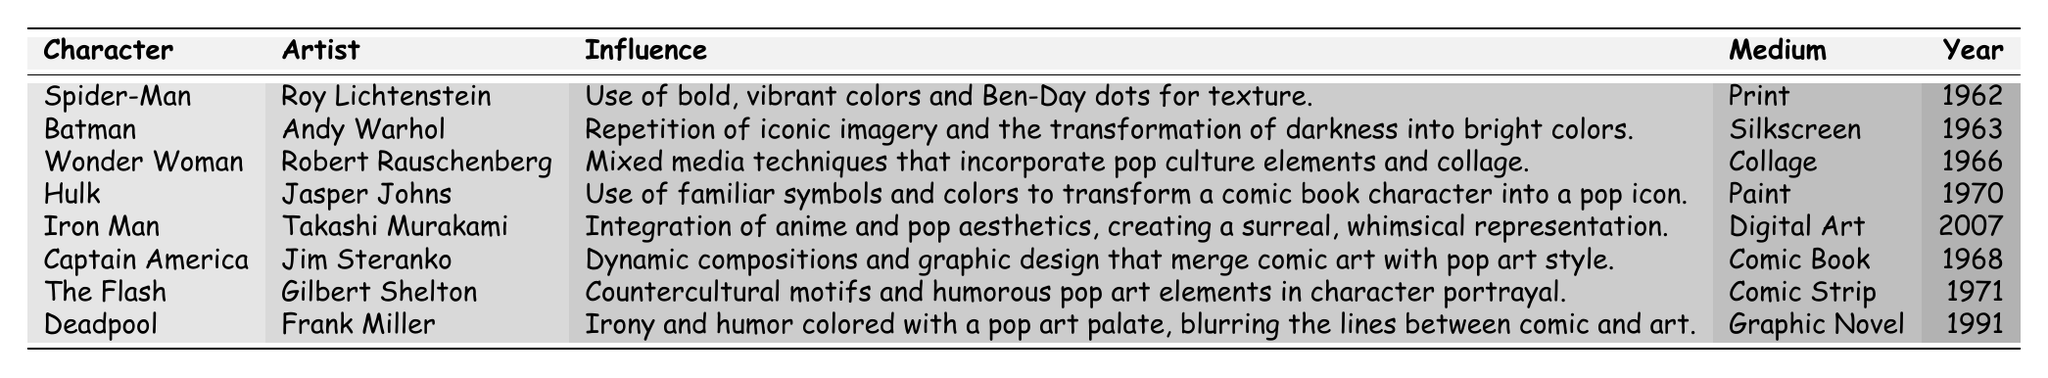What year was Spider-Man influenced by Roy Lichtenstein? The table shows that Spider-Man was influenced by Roy Lichtenstein in the year 1962.
Answer: 1962 Which comic book character was influenced by Andy Warhol? The table indicates that Batman was the character influenced by Andy Warhol.
Answer: Batman What medium did Robert Rauschenberg use for Wonder Woman? According to the table, Robert Rauschenberg used collage as the medium for Wonder Woman.
Answer: Collage How many characters were influenced by artists before 1970? The characters influenced before 1970 are Spider-Man, Batman, Wonder Woman, and Hulk, totaling 4 characters.
Answer: 4 Is it true that Deadpool's influence includes irony and humor? Yes, the table states that Deadpool's influence involved irony and humor colored with a pop art palette.
Answer: Yes Which character was influenced by the artist Jim Steranko? The table shows that Captain America was influenced by Jim Steranko.
Answer: Captain America What is the difference in years between the influences of Hulk and Iron Man? The Hulk was influenced in 1970 and Iron Man in 2007, giving a difference of 37 years (2007 - 1970 = 37).
Answer: 37 Which characters were influenced by artists known for using mixed media techniques? The table shows that Wonder Woman, influenced by Robert Rauschenberg, is the only character associated with mixed media techniques.
Answer: Wonder Woman Which character's design reflects a combination of anime and pop aesthetics? Iron Man's design is noted for integrating anime and pop aesthetics.
Answer: Iron Man What is the average year of influence for characters listed in the table? The years of influence are 1962, 1963, 1966, 1970, 2007, 1968, 1971, and 1991. Adding these gives 1962 + 1963 + 1966 + 1970 + 2007 + 1968 + 1971 + 1991 = 15,788. Dividing by 8 (the number of characters) gives an average of approximately 1973.5.
Answer: 1973.5 